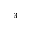<formula> <loc_0><loc_0><loc_500><loc_500>^ { 3 }</formula> 